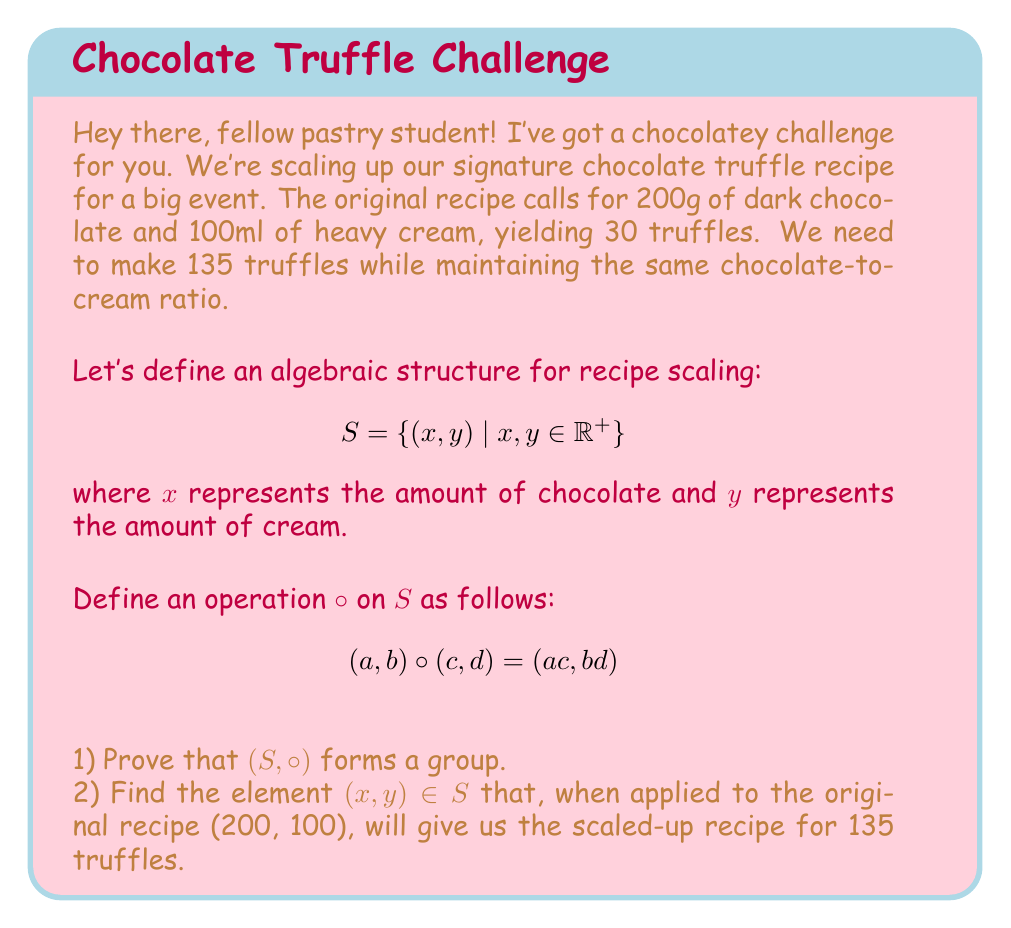What is the answer to this math problem? Let's approach this step-by-step:

1) To prove that $(S, \circ)$ forms a group, we need to show four properties: closure, associativity, identity, and inverse.

   a) Closure: For any $(a, b), (c, d) \in S$, $(a, b) \circ (c, d) = (ac, bd)$. Since $a, b, c, d \in \mathbb{R}^+$, $ac, bd \in \mathbb{R}^+$, so $(ac, bd) \in S$.

   b) Associativity: For any $(a, b), (c, d), (e, f) \in S$,
      $((a, b) \circ (c, d)) \circ (e, f) = (ac, bd) \circ (e, f) = (ace, bdf)$
      $(a, b) \circ ((c, d) \circ (e, f)) = (a, b) \circ (ce, df) = (ace, bdf)$

   c) Identity: The element $(1, 1)$ serves as the identity, since for any $(a, b) \in S$,
      $(a, b) \circ (1, 1) = (1, 1) \circ (a, b) = (a, b)$

   d) Inverse: For any $(a, b) \in S$, its inverse is $(\frac{1}{a}, \frac{1}{b})$, since
      $(a, b) \circ (\frac{1}{a}, \frac{1}{b}) = (\frac{1}{a}, \frac{1}{b}) \circ (a, b) = (1, 1)$

   Therefore, $(S, \circ)$ forms a group.

2) To scale the recipe, we need to find $(x, y)$ such that:
   $(200, 100) \circ (x, y) = (200x, 100y)$, where $200x$ and $100y$ are the new amounts for 135 truffles.

   We know that the ratio of chocolate to cream must remain the same:
   $\frac{200x}{100y} = \frac{200}{100} = 2$

   We also know that the new recipe should make 135 truffles, which is 4.5 times the original 30 truffles.
   So, $x = y = 4.5$

   We can verify: $(200, 100) \circ (4.5, 4.5) = (900, 450)$

   Indeed, 900g of chocolate and 450ml of cream maintain the 2:1 ratio and scale the recipe by 4.5 times.
Answer: $(4.5, 4.5)$ 